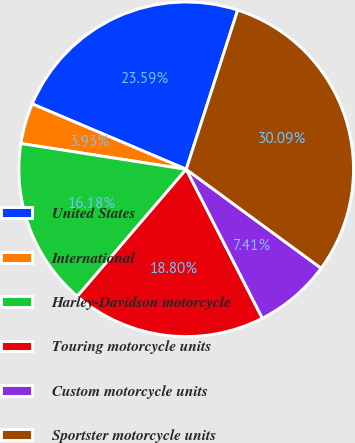<chart> <loc_0><loc_0><loc_500><loc_500><pie_chart><fcel>United States<fcel>International<fcel>Harley-Davidson motorcycle<fcel>Touring motorcycle units<fcel>Custom motorcycle units<fcel>Sportster motorcycle units<nl><fcel>23.59%<fcel>3.93%<fcel>16.18%<fcel>18.8%<fcel>7.41%<fcel>30.09%<nl></chart> 